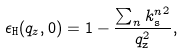Convert formula to latex. <formula><loc_0><loc_0><loc_500><loc_500>\epsilon _ { \tt H } ( q _ { z } , 0 ) = 1 - \frac { \sum _ { n } { k _ { \tt s } ^ { n } } ^ { 2 } } { q _ { \tt z } ^ { 2 } } ,</formula> 